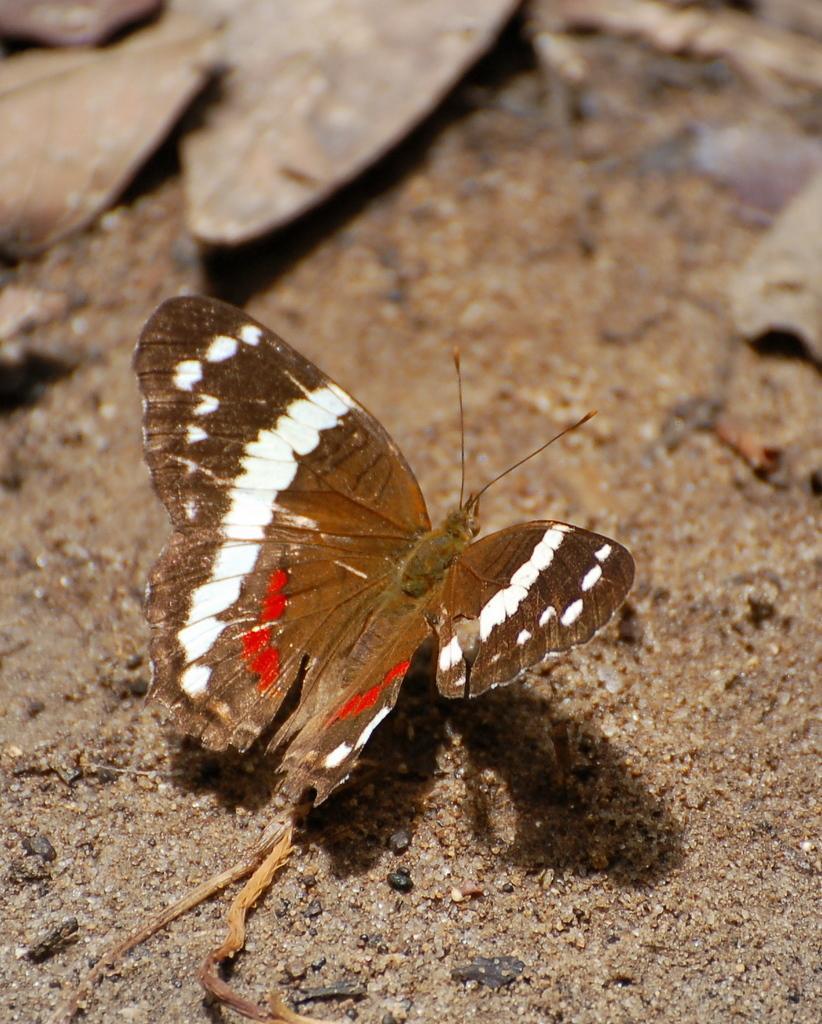Please provide a concise description of this image. In this image I can see a butterfly which is in brown, white and red color. It is on the ground. In the background I think there are some dried leaves on the ground but it is blurry. 